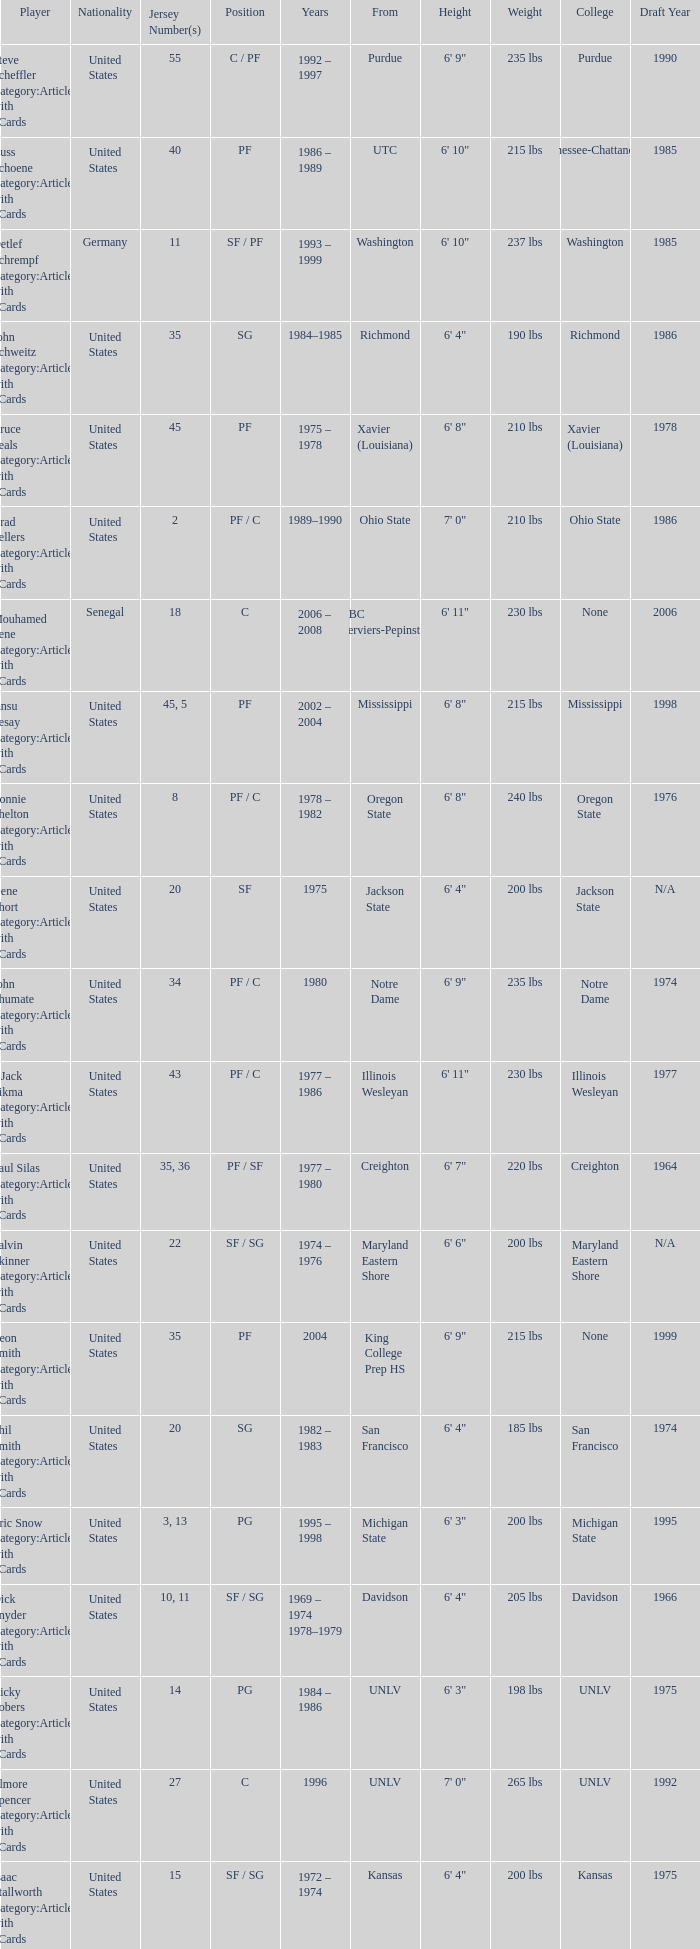Who wears the jersey number 20 and has the position of SG? Phil Smith Category:Articles with hCards, Jon Sundvold Category:Articles with hCards. 